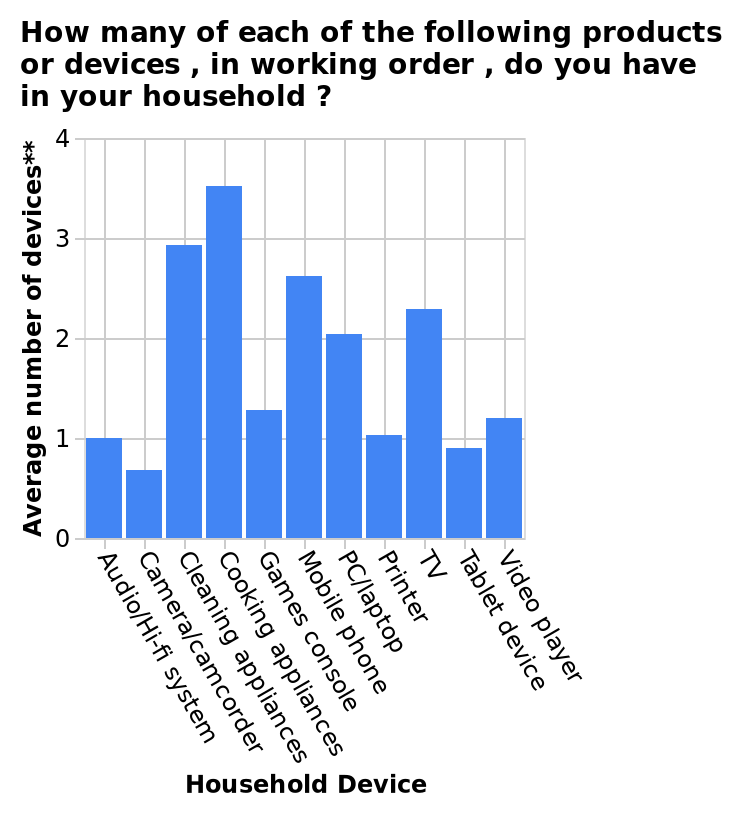<image>
Where are higher priced devices likely to be seen? In less households. please summary the statistics and relations of the chart Cleaning and cooking appliances hold the largest number of devices per household, which indicates the necessity of both of these chores. Higher priced devices would be seen in less houeholds. What does the large number of cleaning and cooking appliances in households indicate? The necessity of both cleaning and cooking chores. 